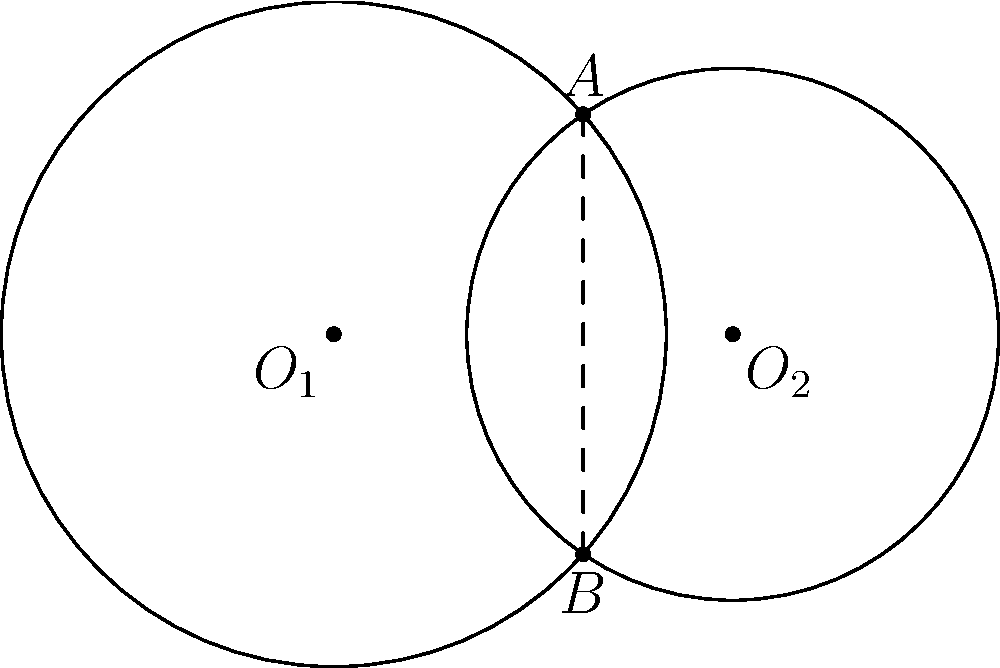Two circles intersect as shown in the figure. Circle 1 has center $O_1$ and radius $r_1 = 2.5$ units, while Circle 2 has center $O_2$ and radius $r_2 = 2$ units. The distance between their centers is 3 units. What is the length of the common chord $AB$? Let's approach this step-by-step, using the power of spiritual geometry to find our answer:

1) First, we need to find the distance from the center of each circle to the common chord. Let's call these distances $h_1$ and $h_2$ for circles 1 and 2 respectively.

2) We can use the Pythagorean theorem to set up two equations:

   $r_1^2 = h_1^2 + (\frac{AB}{2})^2$ for Circle 1
   $r_2^2 = h_2^2 + (\frac{AB}{2})^2$ for Circle 2

3) We also know that the distance between the centers is 3 units, so:

   $h_1 + h_2 = 3$

4) Substituting the known values:

   $2.5^2 = h_1^2 + (\frac{AB}{2})^2$
   $2^2 = h_2^2 + (\frac{AB}{2})^2$

5) Subtracting the second equation from the first:

   $2.5^2 - 2^2 = h_1^2 - h_2^2$
   $6.25 - 4 = h_1^2 - h_2^2$
   $2.25 = h_1^2 - h_2^2$

6) We can factor this as:

   $2.25 = (h_1 + h_2)(h_1 - h_2)$

7) We know $h_1 + h_2 = 3$, so:

   $2.25 = 3(h_1 - h_2)$
   $h_1 - h_2 = 0.75$

8) Now we have two equations:

   $h_1 + h_2 = 3$
   $h_1 - h_2 = 0.75$

9) Adding these equations:

   $2h_1 = 3.75$
   $h_1 = 1.875$

10) Now we can find $(\frac{AB}{2})^2$:

    $(\frac{AB}{2})^2 = 2.5^2 - 1.875^2 = 6.25 - 3.515625 = 2.734375$

11) Therefore:

    $AB = 2\sqrt{2.734375} \approx 3.307$ units

Through this spiritual journey of geometric exploration, we've discovered the length of the common chord.
Answer: $3.307$ units 